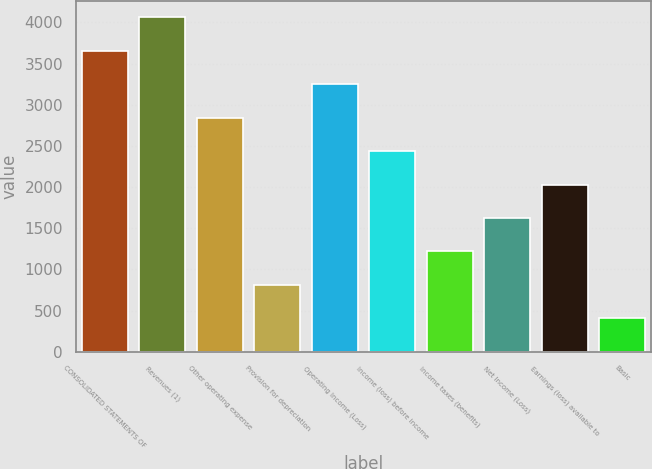Convert chart. <chart><loc_0><loc_0><loc_500><loc_500><bar_chart><fcel>CONSOLIDATED STATEMENTS OF<fcel>Revenues (1)<fcel>Other operating expense<fcel>Provision for depreciation<fcel>Operating Income (Loss)<fcel>Income (loss) before income<fcel>Income taxes (benefits)<fcel>Net Income (Loss)<fcel>Earnings (loss) available to<fcel>Basic<nl><fcel>3653.21<fcel>4059.01<fcel>2841.61<fcel>812.61<fcel>3247.41<fcel>2435.81<fcel>1218.41<fcel>1624.21<fcel>2030.01<fcel>406.81<nl></chart> 